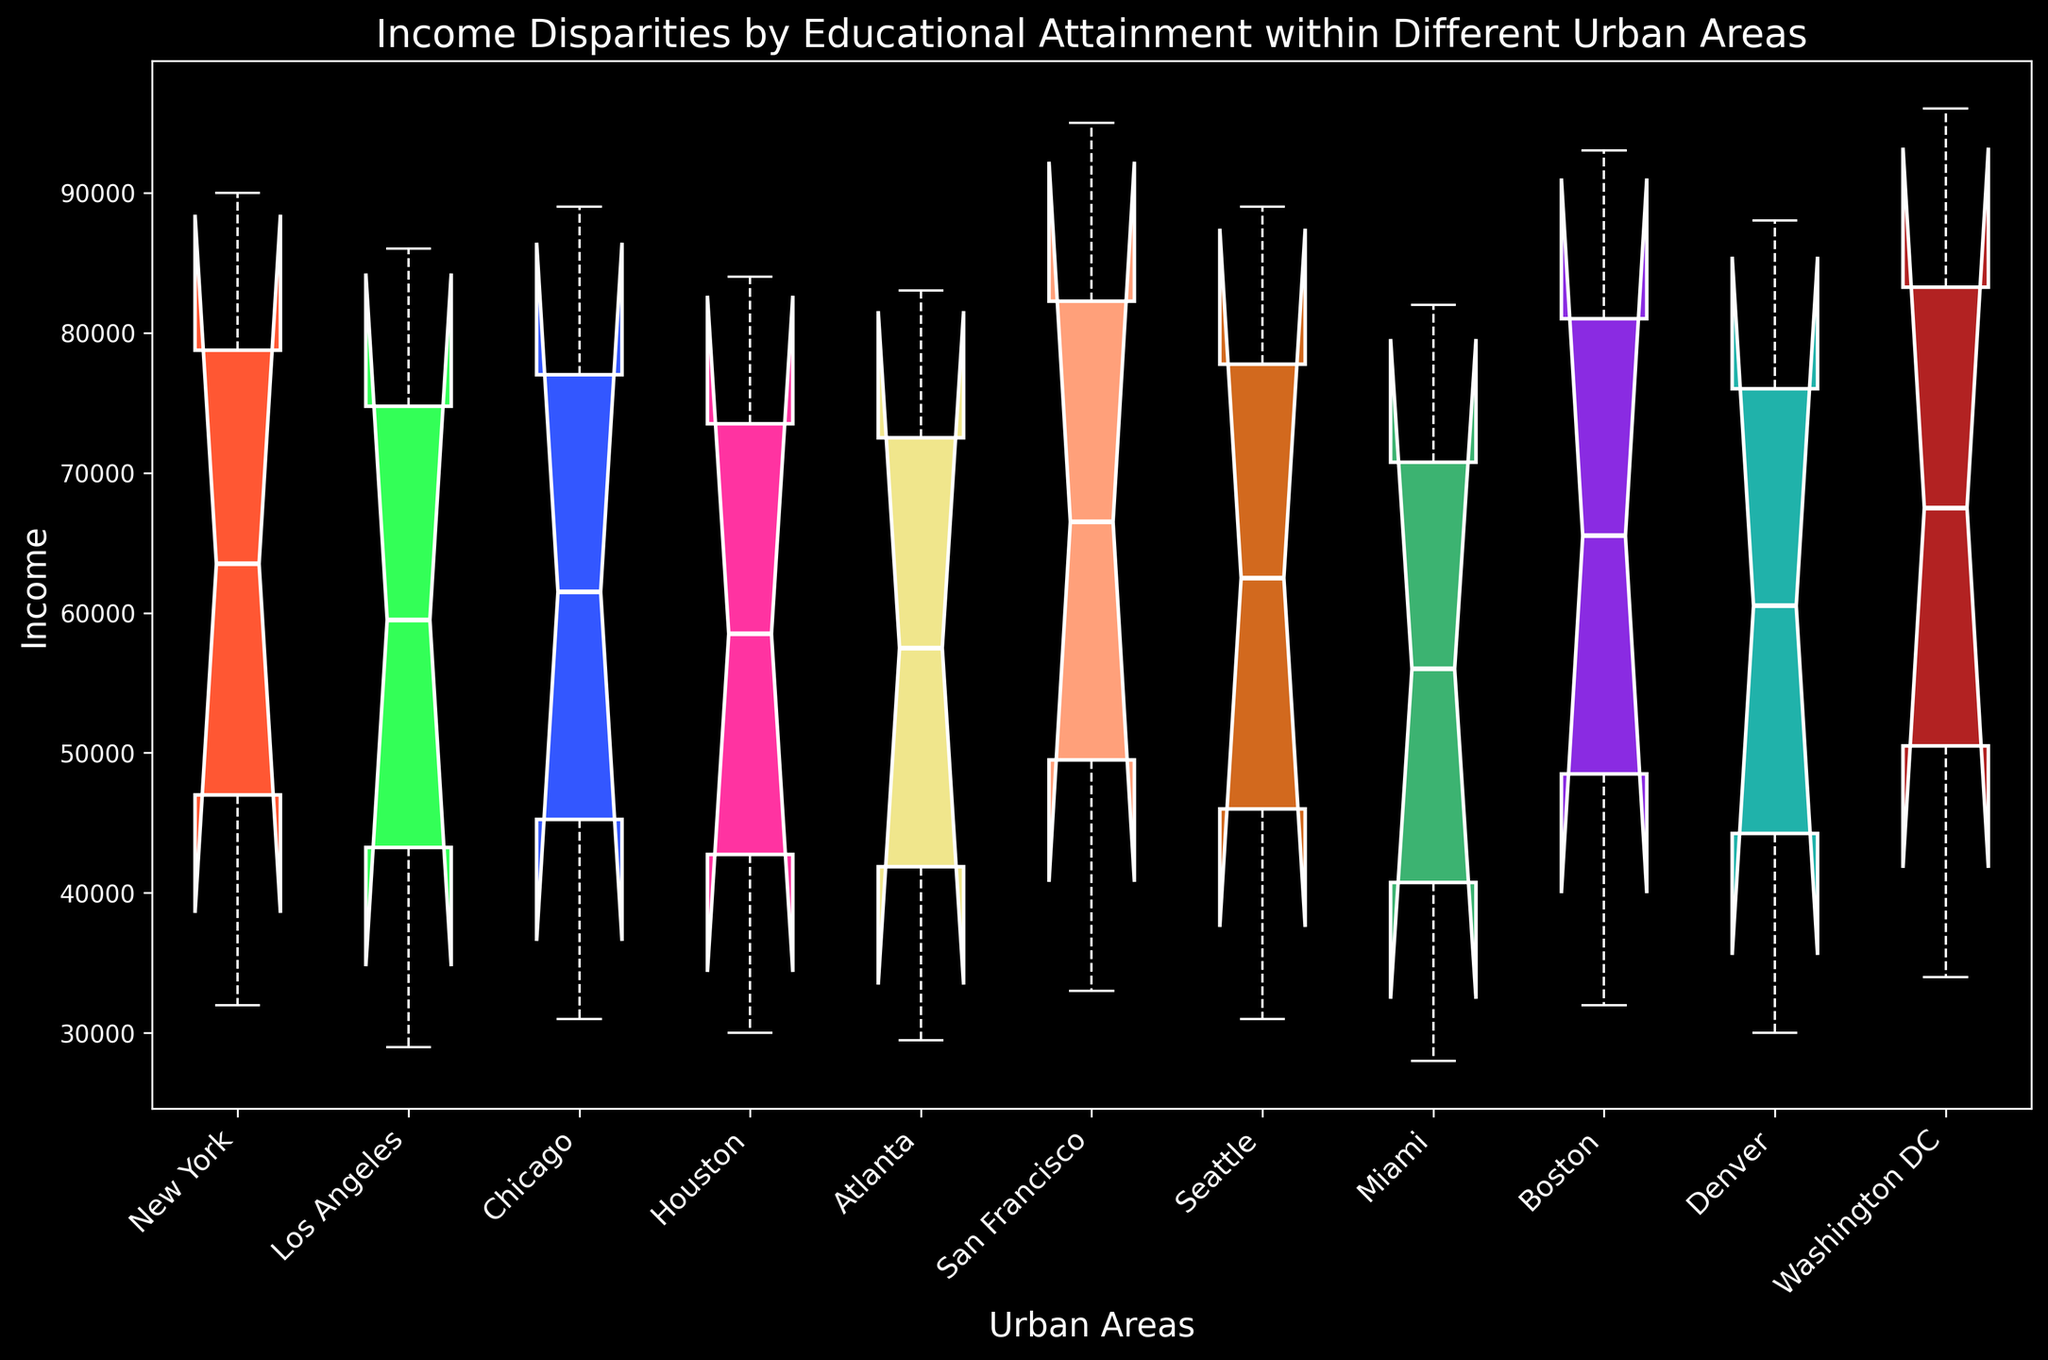What is the median income for those with a Bachelor's degree across all urban areas? To determine this, we need to look at the median lines within each box that represents those with a Bachelor's degree across all urban areas. These lines will give us the income values that are at the 50th percentile for each area.
Answer: Varies by area Which urban area has the highest income for those with a Doctorate degree? By comparing the top ends of the boxes that represent Doctorate degrees, we can see which urban area reaches the highest income level.
Answer: Washington DC Which urban area has the lowest median income for those with a High School diploma? To find this, we need to locate the box plot for individuals with a High School diploma and compare the median lines across different areas. The lowest among these medians is the answer.
Answer: Miami What is the income range (difference between maximum and minimum) for Master's degree holders in New York? We identify the box plot corresponding to Master's degree holders in New York, then calculate the range by subtracting the minimum income value (bottom whisker) from the maximum income value (top whisker).
Answer: 43000 Which urban area shows the most significant disparity (range) in income between High School and Doctorate degree holders? To answer this, we need to find the range for High School and Doctorate incomes for each urban area and then compare these ranges to see which has the largest difference.
Answer: Washington DC In terms of visual attributes, what color is used to represent the incomes in San Francisco? Look at the specific box plot for San Francisco and identify the color used to fill the box.
Answer: Color chosen for San Francisco (e.g., Khaki or F0E68C in this case) Considering all urban areas, what is the overall trend in income as educational attainment increases? By observing the positions of box plots across different education levels (from High School to Doctorate), we can discern if there's a general upward trend in income.
Answer: Increasing trend How does the median income for Bachelor's degrees in Los Angeles compare to New York? Compare the median lines within the boxes representing Bachelor's degree holders in both Los Angeles and New York to see which is higher.
Answer: Los Angeles is lower Which educational attainment level has the most similar median incomes across all urban areas? By comparing the median lines of each educational attainment level across all urban areas, we can determine which one has the least variation.
Answer: Bachelor's degree What is the income difference between the median incomes for Master's and Doctorate degree holders in Seattle? First, locate Seattle's box plots for Master's and Doctorate degrees, then subtract the median income of Master's degree holders from that of Doctorate degree holders.
Answer: 15000 